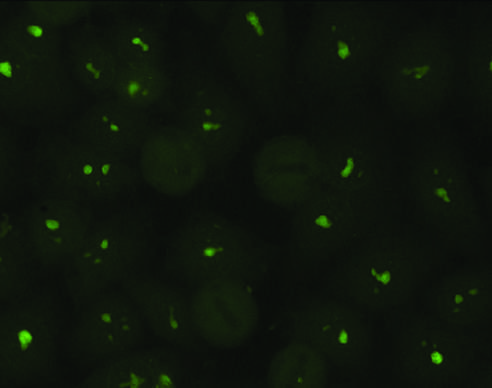s the late-phase reaction typical of antibodies against nucleolar proteins?
Answer the question using a single word or phrase. No 